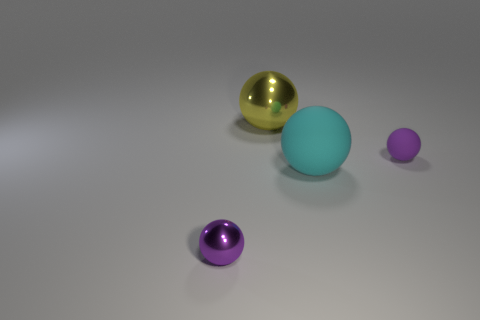There is a object that is both behind the big cyan rubber thing and in front of the large yellow metallic thing; how big is it?
Offer a terse response. Small. There is a metal sphere behind the tiny purple thing that is right of the yellow sphere; what color is it?
Make the answer very short. Yellow. Is the number of small purple balls behind the purple shiny thing less than the number of objects that are left of the tiny purple rubber ball?
Your answer should be compact. Yes. Is the yellow thing the same size as the cyan ball?
Keep it short and to the point. Yes. The thing that is in front of the small rubber sphere and right of the small shiny ball has what shape?
Your answer should be compact. Sphere. What number of small cylinders have the same material as the cyan ball?
Your answer should be very brief. 0. What number of tiny purple matte balls are in front of the small purple ball on the left side of the cyan ball?
Give a very brief answer. 0. What shape is the large object behind the purple sphere that is to the right of the purple sphere on the left side of the large cyan matte thing?
Give a very brief answer. Sphere. The metallic ball that is the same color as the tiny rubber sphere is what size?
Give a very brief answer. Small. What number of things are large red metallic things or big matte balls?
Provide a succinct answer. 1. 